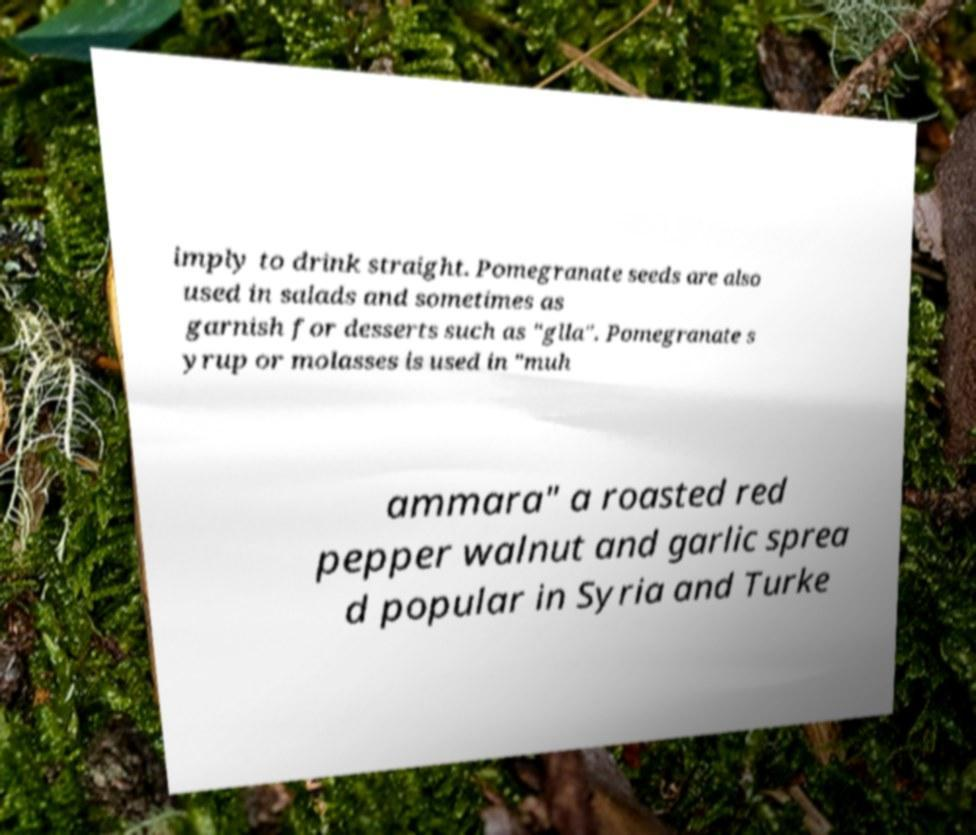Please read and relay the text visible in this image. What does it say? imply to drink straight. Pomegranate seeds are also used in salads and sometimes as garnish for desserts such as "glla". Pomegranate s yrup or molasses is used in "muh ammara" a roasted red pepper walnut and garlic sprea d popular in Syria and Turke 